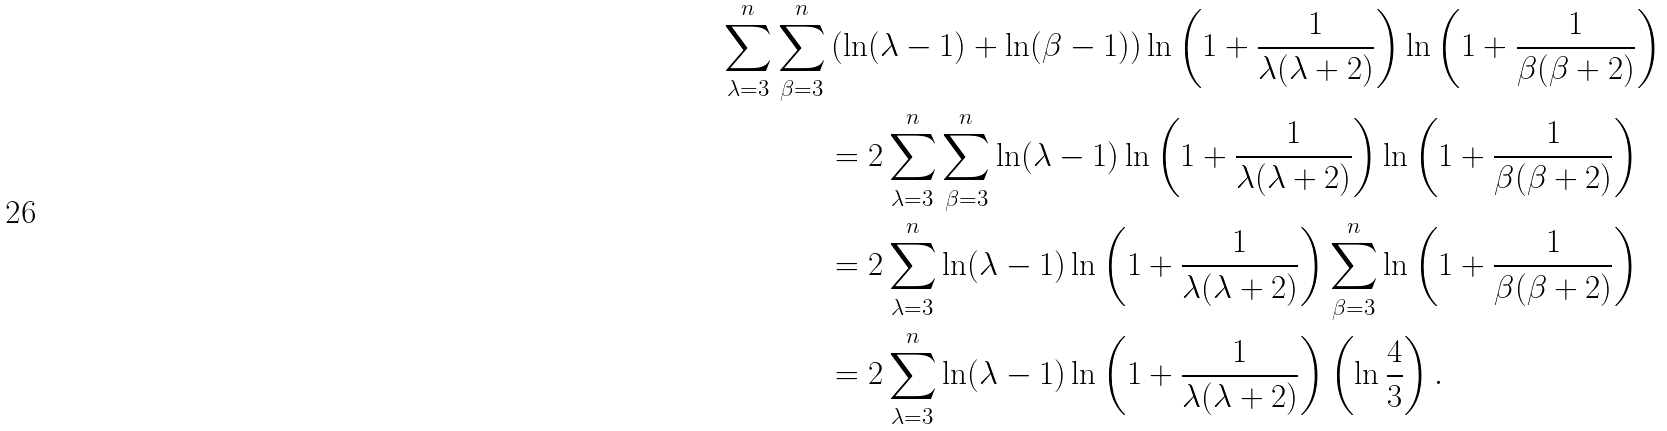<formula> <loc_0><loc_0><loc_500><loc_500>\sum _ { \lambda = 3 } ^ { n } \sum _ { \beta = 3 } ^ { n } & \left ( \ln ( \lambda - 1 ) + \ln ( \beta - 1 ) \right ) \ln \left ( 1 + \frac { 1 } { \lambda ( \lambda + 2 ) } \right ) \ln \left ( 1 + \frac { 1 } { \beta ( \beta + 2 ) } \right ) \\ & = 2 \sum _ { \lambda = 3 } ^ { n } \sum _ { \beta = 3 } ^ { n } \ln ( \lambda - 1 ) \ln \left ( 1 + \frac { 1 } { \lambda ( \lambda + 2 ) } \right ) \ln \left ( 1 + \frac { 1 } { \beta ( \beta + 2 ) } \right ) \\ & = 2 \sum _ { \lambda = 3 } ^ { n } \ln ( \lambda - 1 ) \ln \left ( 1 + \frac { 1 } { \lambda ( \lambda + 2 ) } \right ) \sum _ { \beta = 3 } ^ { n } \ln \left ( 1 + \frac { 1 } { \beta ( \beta + 2 ) } \right ) \\ & = 2 \sum _ { \lambda = 3 } ^ { n } \ln ( \lambda - 1 ) \ln \left ( 1 + \frac { 1 } { \lambda ( \lambda + 2 ) } \right ) \left ( \ln \frac { 4 } { 3 } \right ) .</formula> 